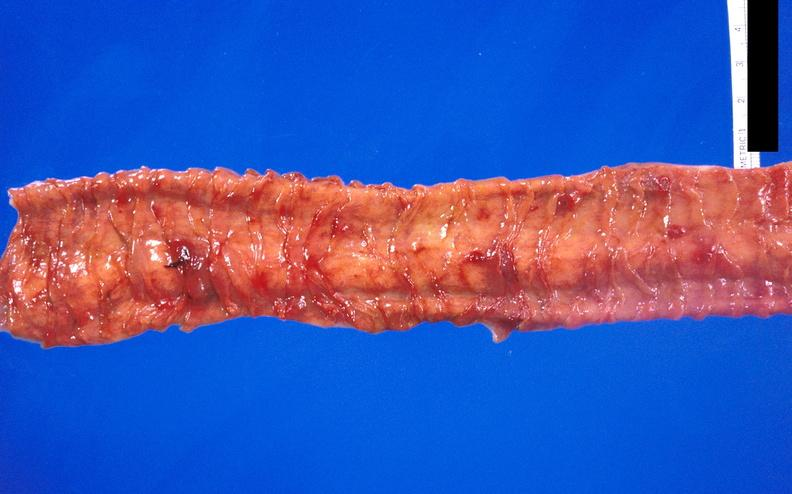does endocervical polyp show hemorrhagic stress ulcers from patient with acute myelogenous leukemia?
Answer the question using a single word or phrase. No 